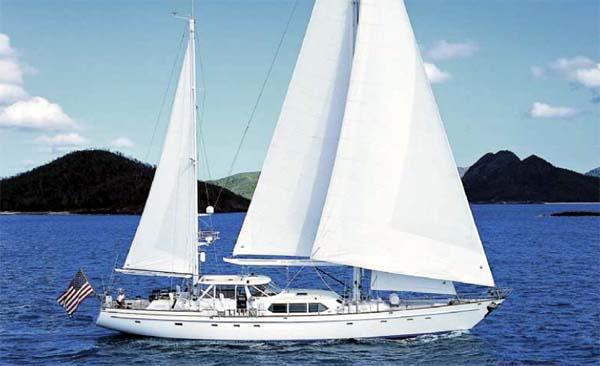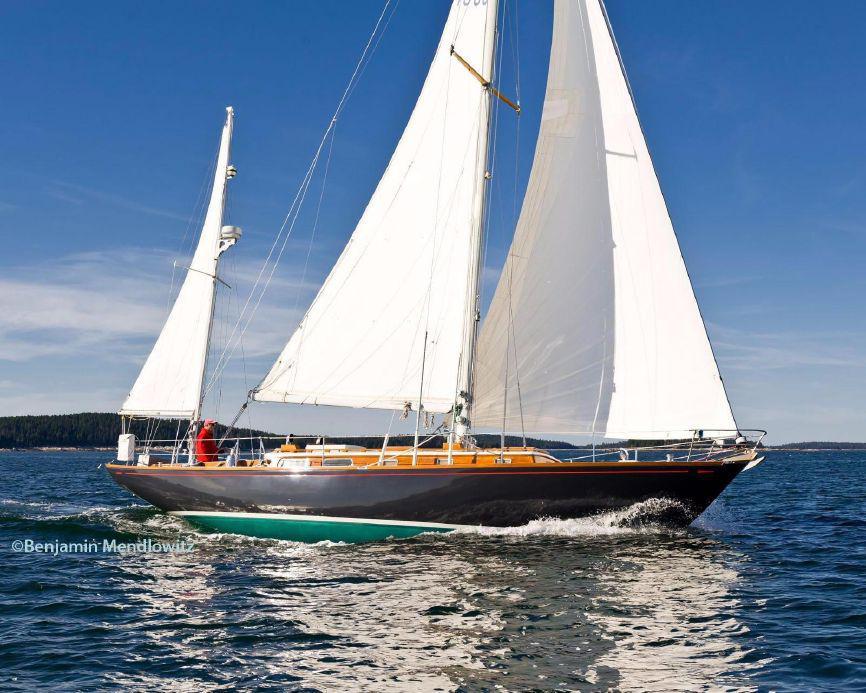The first image is the image on the left, the second image is the image on the right. Analyze the images presented: Is the assertion "A sailboat moving on deep-blue water has a non-white exterior boat body." valid? Answer yes or no. Yes. The first image is the image on the left, the second image is the image on the right. Given the left and right images, does the statement "A landform sits in the distance behind the boat in the image on the left." hold true? Answer yes or no. Yes. 